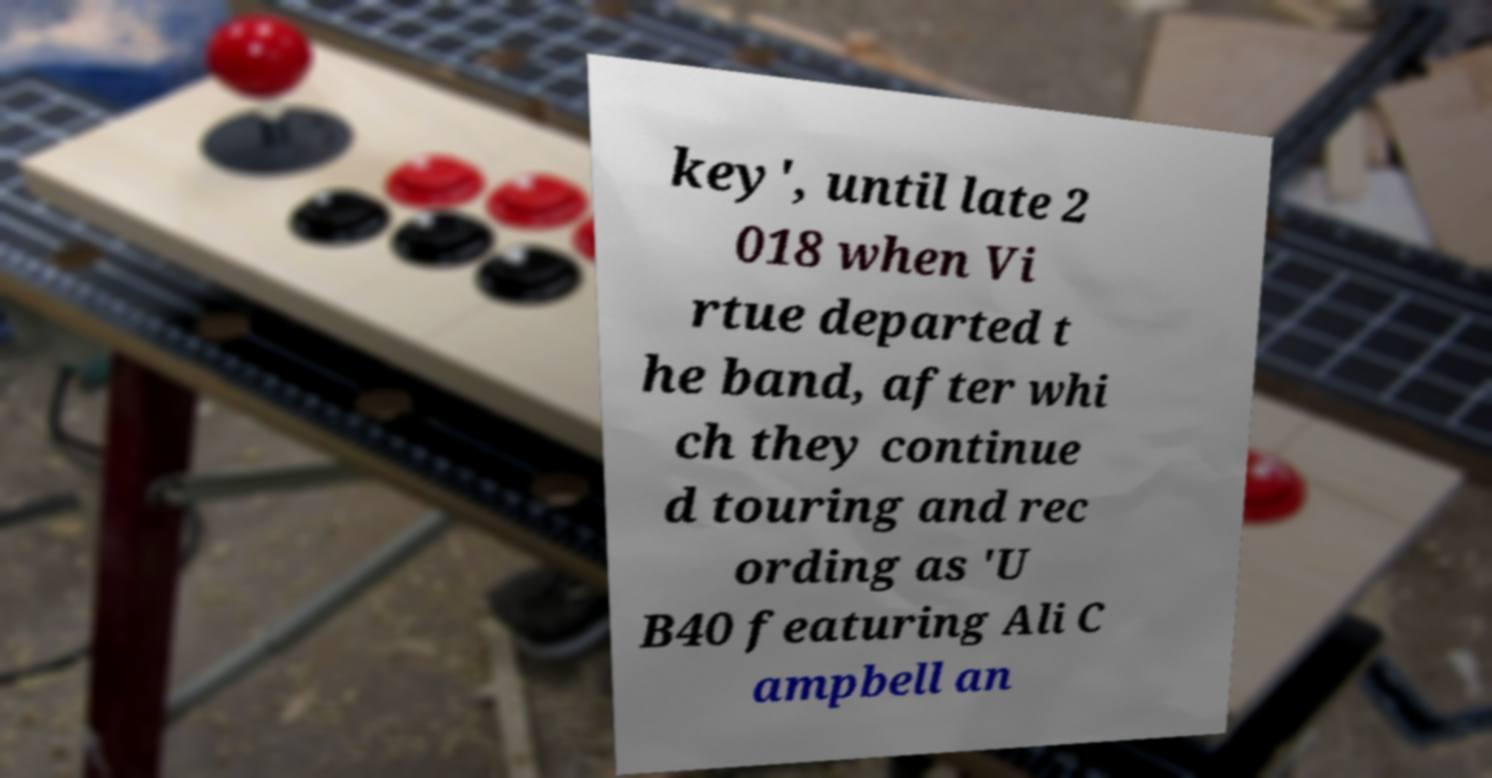Could you assist in decoding the text presented in this image and type it out clearly? key', until late 2 018 when Vi rtue departed t he band, after whi ch they continue d touring and rec ording as 'U B40 featuring Ali C ampbell an 